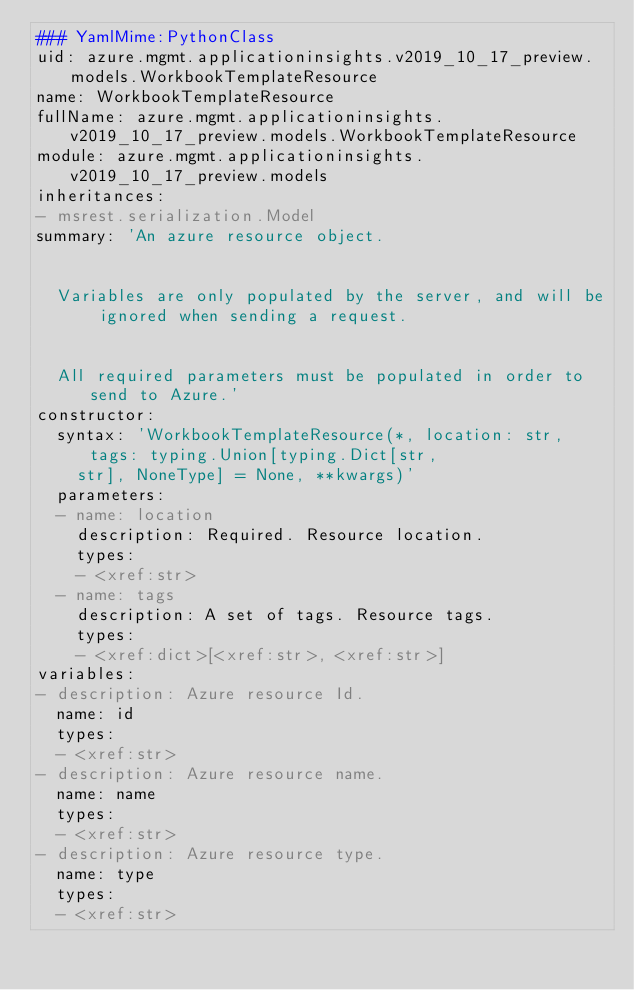<code> <loc_0><loc_0><loc_500><loc_500><_YAML_>### YamlMime:PythonClass
uid: azure.mgmt.applicationinsights.v2019_10_17_preview.models.WorkbookTemplateResource
name: WorkbookTemplateResource
fullName: azure.mgmt.applicationinsights.v2019_10_17_preview.models.WorkbookTemplateResource
module: azure.mgmt.applicationinsights.v2019_10_17_preview.models
inheritances:
- msrest.serialization.Model
summary: 'An azure resource object.


  Variables are only populated by the server, and will be ignored when sending a request.


  All required parameters must be populated in order to send to Azure.'
constructor:
  syntax: 'WorkbookTemplateResource(*, location: str, tags: typing.Union[typing.Dict[str,
    str], NoneType] = None, **kwargs)'
  parameters:
  - name: location
    description: Required. Resource location.
    types:
    - <xref:str>
  - name: tags
    description: A set of tags. Resource tags.
    types:
    - <xref:dict>[<xref:str>, <xref:str>]
variables:
- description: Azure resource Id.
  name: id
  types:
  - <xref:str>
- description: Azure resource name.
  name: name
  types:
  - <xref:str>
- description: Azure resource type.
  name: type
  types:
  - <xref:str>
</code> 